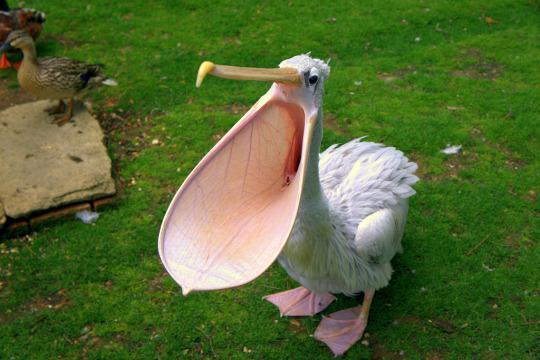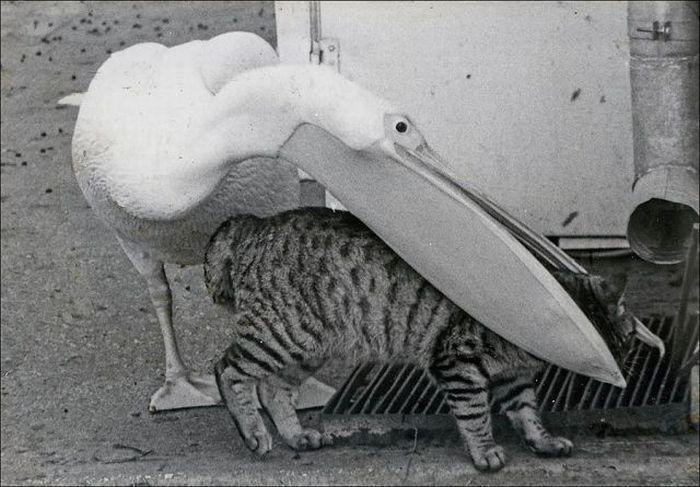The first image is the image on the left, the second image is the image on the right. Analyze the images presented: Is the assertion "In one image, a pelican's beak is open wide so the inside can be seen, while in the other image, a pelican has an animal caught in its beak." valid? Answer yes or no. Yes. The first image is the image on the left, the second image is the image on the right. Given the left and right images, does the statement "One image shows a pelican with its bill closing around the head of an animal that is not a fish, and the other image shows a forward facing open-mouthed pelican." hold true? Answer yes or no. Yes. 